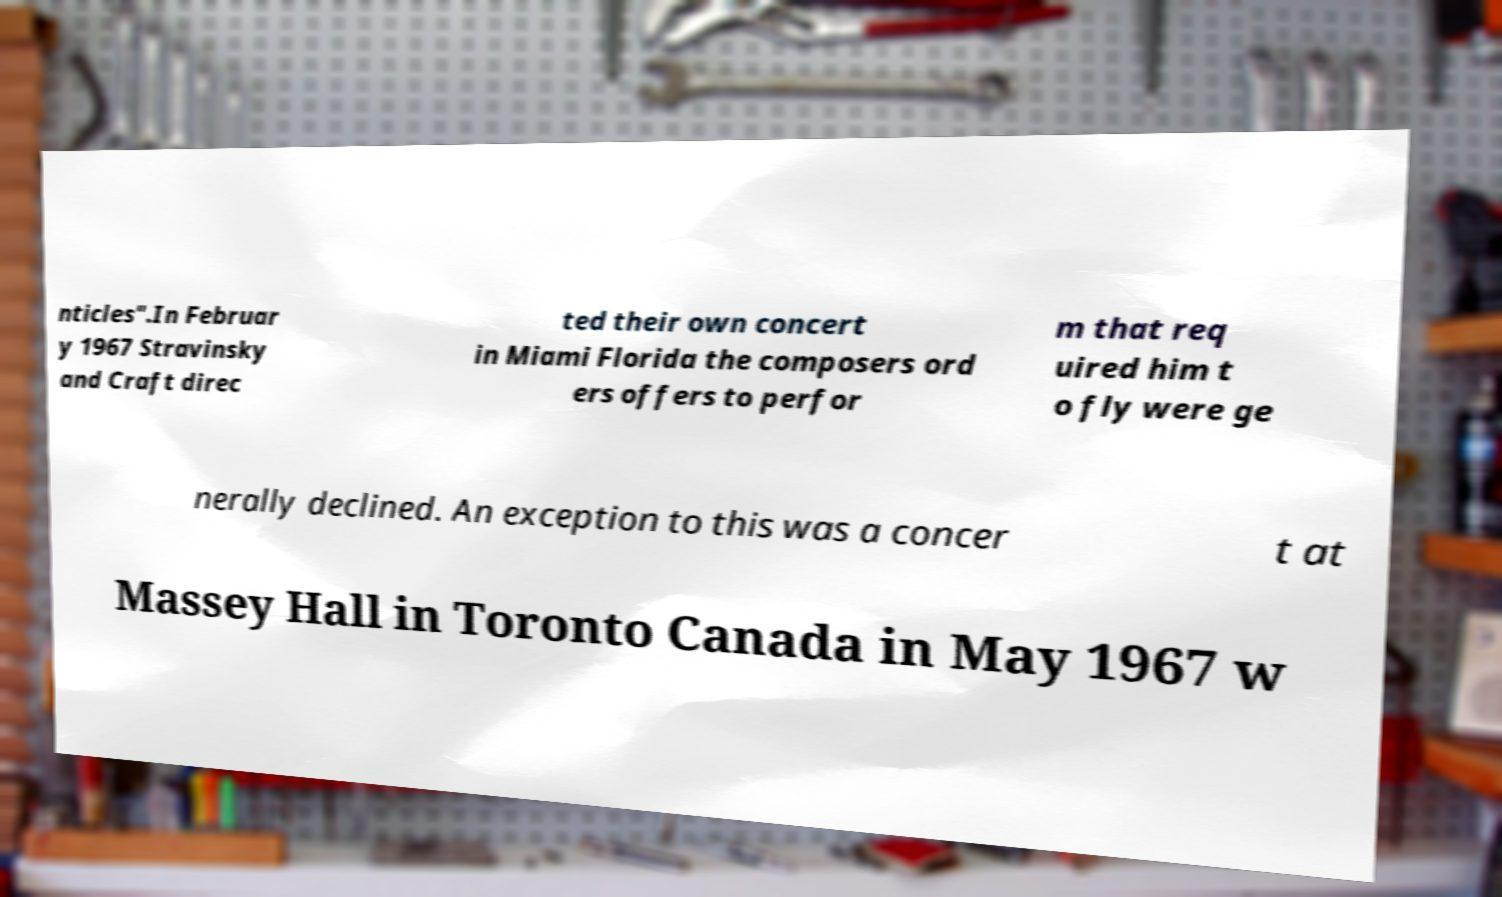For documentation purposes, I need the text within this image transcribed. Could you provide that? nticles".In Februar y 1967 Stravinsky and Craft direc ted their own concert in Miami Florida the composers ord ers offers to perfor m that req uired him t o fly were ge nerally declined. An exception to this was a concer t at Massey Hall in Toronto Canada in May 1967 w 